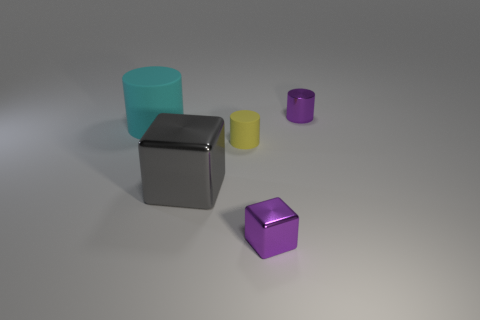Is the material of the small yellow cylinder on the left side of the tiny purple shiny cube the same as the cyan object?
Give a very brief answer. Yes. There is a purple metal object that is in front of the tiny shiny object behind the cylinder that is to the left of the large shiny thing; what is its shape?
Ensure brevity in your answer.  Cube. Is the number of large gray metallic blocks behind the cyan cylinder the same as the number of tiny cylinders on the left side of the small matte cylinder?
Offer a very short reply. Yes. What color is the object that is the same size as the cyan rubber cylinder?
Your answer should be compact. Gray. How many tiny objects are cylinders or purple matte balls?
Your answer should be compact. 2. There is a object that is to the left of the small purple block and behind the yellow thing; what material is it?
Give a very brief answer. Rubber. Do the tiny purple thing that is behind the gray block and the purple object that is in front of the tiny purple metallic cylinder have the same shape?
Offer a very short reply. No. The tiny shiny thing that is the same color as the small metallic cube is what shape?
Provide a succinct answer. Cylinder. How many objects are things left of the large gray metallic block or small shiny things?
Make the answer very short. 3. Does the purple metallic cylinder have the same size as the gray thing?
Your response must be concise. No. 